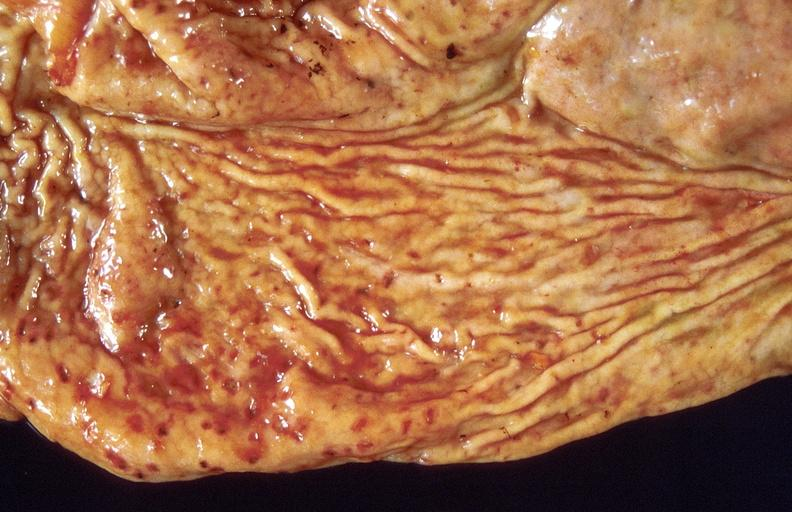does situs inversus show stress ulcers, stomach?
Answer the question using a single word or phrase. No 